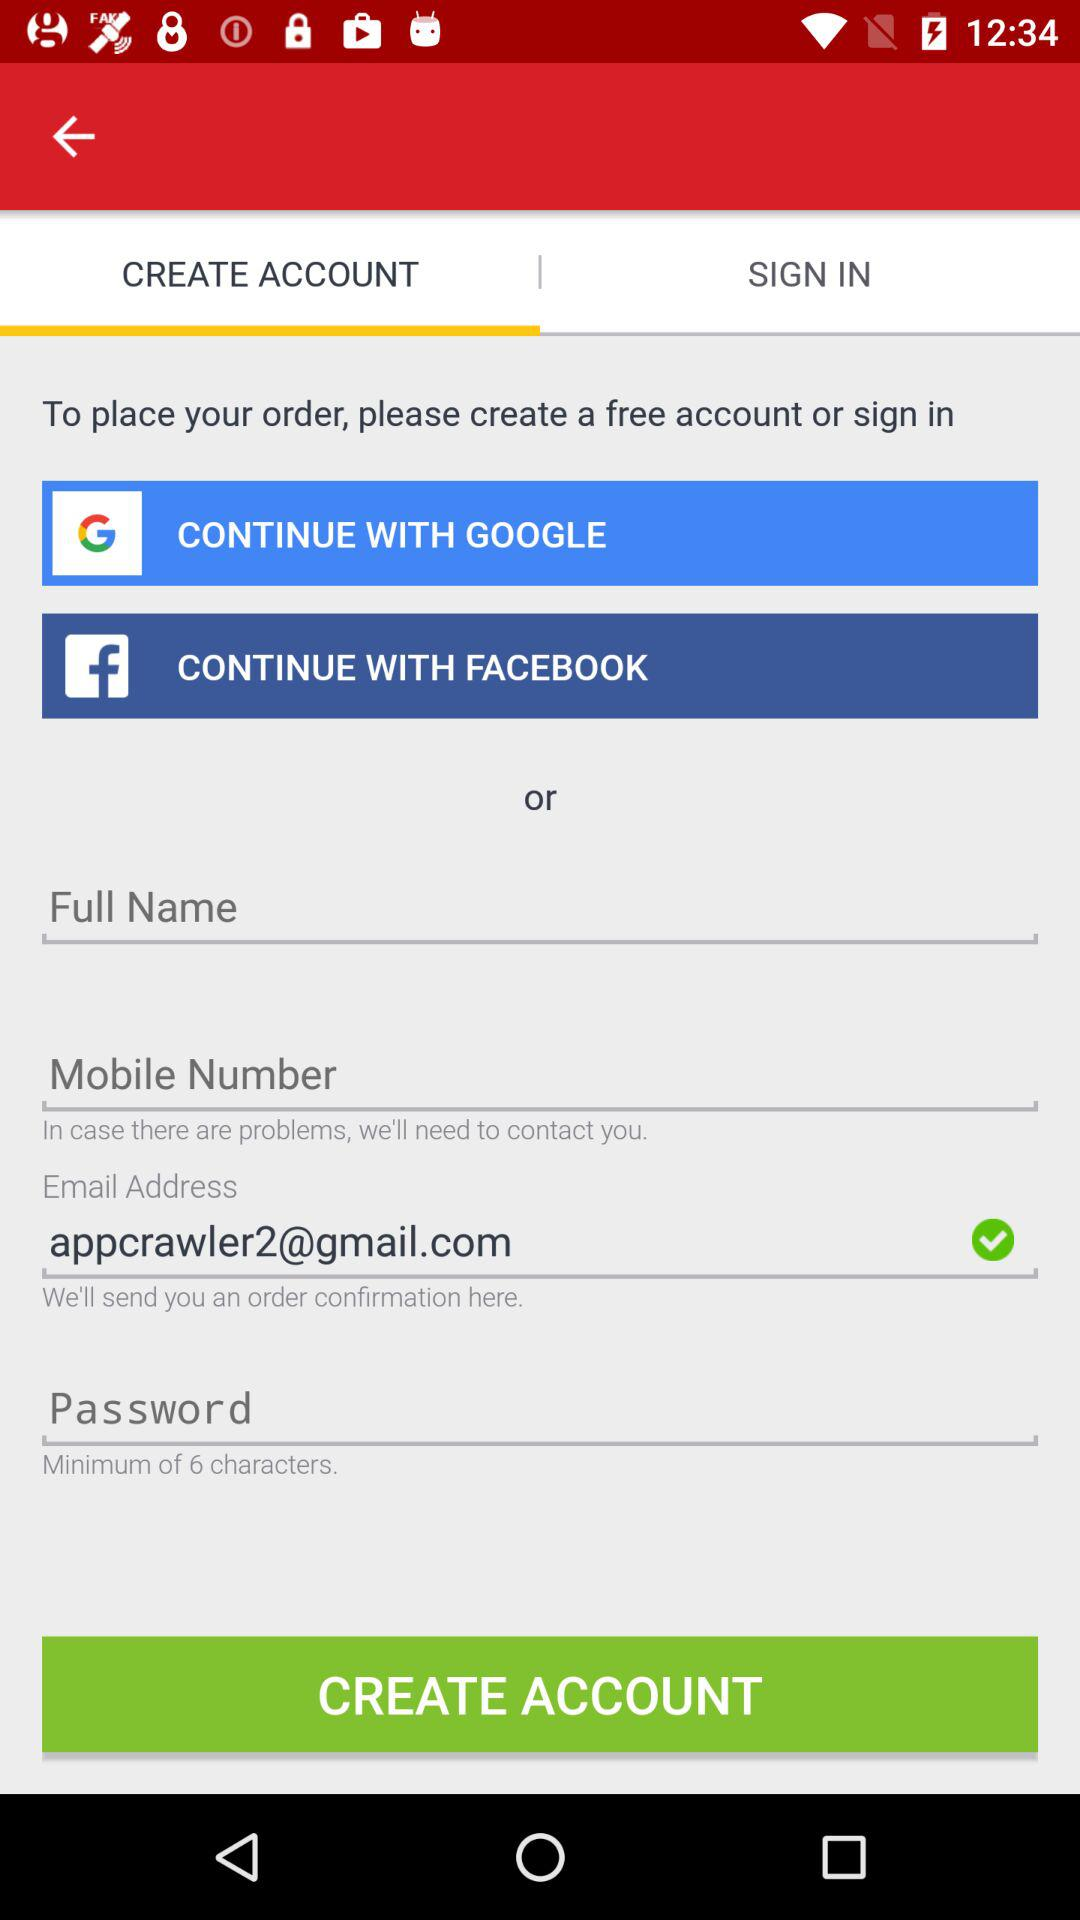What accounts can be used to continue? The accounts are "GOOGLE" and "FACEBOOK". 